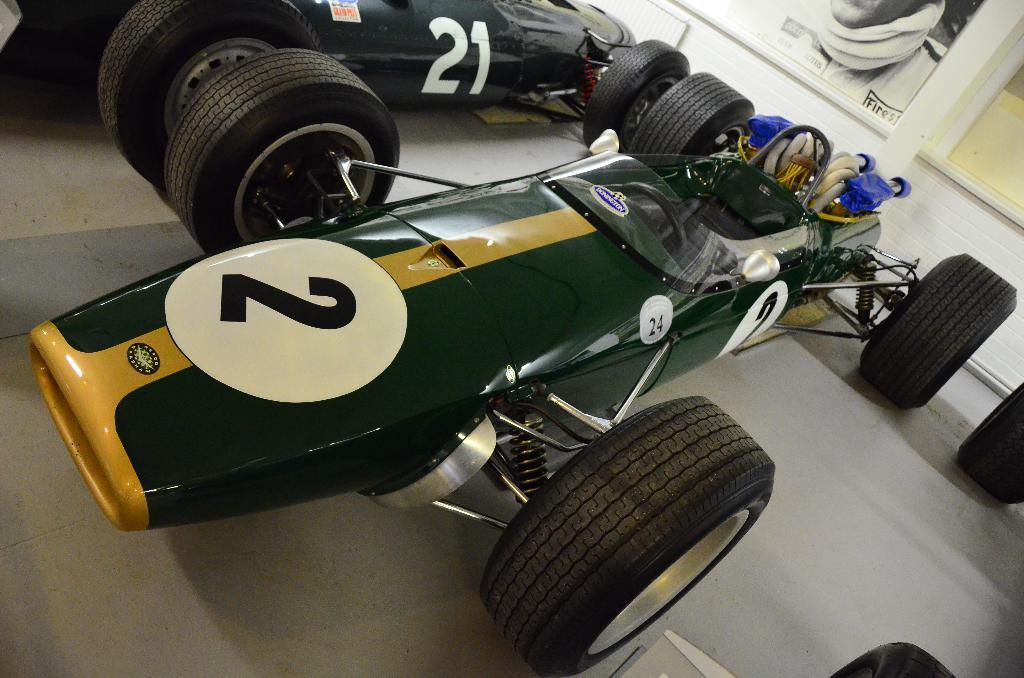What type of vehicles are in the image? There are racing cars in the image. What can be seen in the background of the image? There is a wall and boards visible in the background of the image. What type of army uniform can be seen on the racing cars in the image? There is no army uniform or any reference to an army in the image; it features racing cars and a background with a wall and boards. 